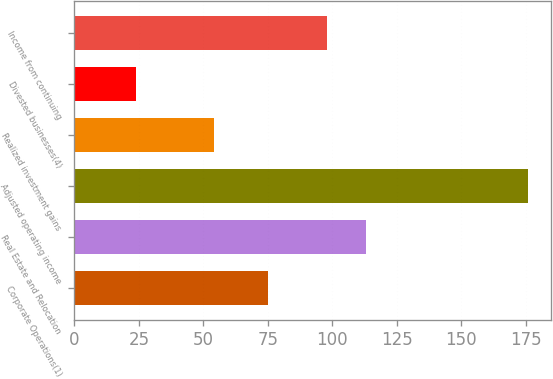Convert chart to OTSL. <chart><loc_0><loc_0><loc_500><loc_500><bar_chart><fcel>Corporate Operations(1)<fcel>Real Estate and Relocation<fcel>Adjusted operating income<fcel>Realized investment gains<fcel>Divested businesses(4)<fcel>Income from continuing<nl><fcel>75<fcel>113.2<fcel>176<fcel>54<fcel>24<fcel>98<nl></chart> 